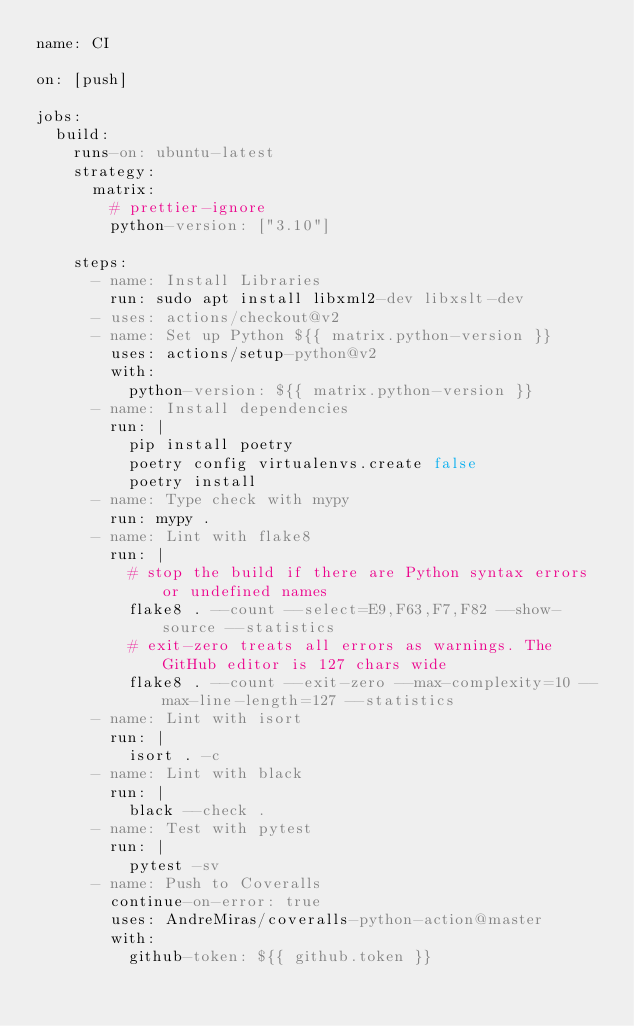Convert code to text. <code><loc_0><loc_0><loc_500><loc_500><_YAML_>name: CI

on: [push]

jobs:
  build:
    runs-on: ubuntu-latest
    strategy:
      matrix:
        # prettier-ignore
        python-version: ["3.10"]

    steps:
      - name: Install Libraries
        run: sudo apt install libxml2-dev libxslt-dev
      - uses: actions/checkout@v2
      - name: Set up Python ${{ matrix.python-version }}
        uses: actions/setup-python@v2
        with:
          python-version: ${{ matrix.python-version }}
      - name: Install dependencies
        run: |
          pip install poetry
          poetry config virtualenvs.create false
          poetry install
      - name: Type check with mypy
        run: mypy .
      - name: Lint with flake8
        run: |
          # stop the build if there are Python syntax errors or undefined names
          flake8 . --count --select=E9,F63,F7,F82 --show-source --statistics
          # exit-zero treats all errors as warnings. The GitHub editor is 127 chars wide
          flake8 . --count --exit-zero --max-complexity=10 --max-line-length=127 --statistics
      - name: Lint with isort
        run: |
          isort . -c
      - name: Lint with black
        run: |
          black --check .
      - name: Test with pytest
        run: |
          pytest -sv
      - name: Push to Coveralls
        continue-on-error: true
        uses: AndreMiras/coveralls-python-action@master
        with:
          github-token: ${{ github.token }}
</code> 